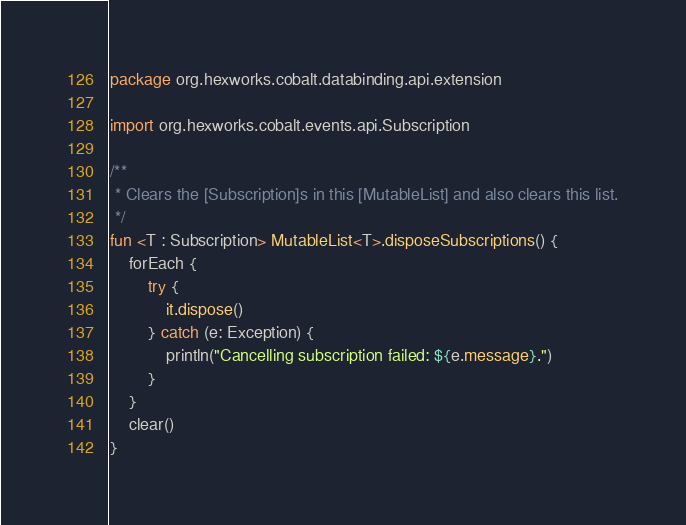<code> <loc_0><loc_0><loc_500><loc_500><_Kotlin_>package org.hexworks.cobalt.databinding.api.extension

import org.hexworks.cobalt.events.api.Subscription

/**
 * Clears the [Subscription]s in this [MutableList] and also clears this list.
 */
fun <T : Subscription> MutableList<T>.disposeSubscriptions() {
    forEach {
        try {
            it.dispose()
        } catch (e: Exception) {
            println("Cancelling subscription failed: ${e.message}.")
        }
    }
    clear()
}
</code> 